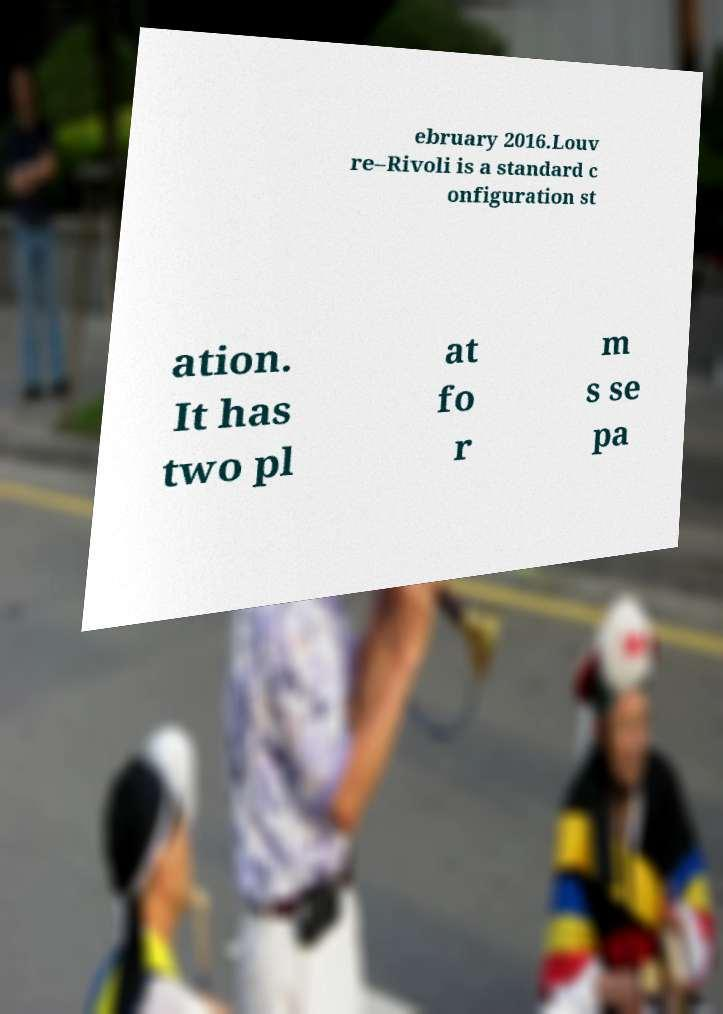Could you assist in decoding the text presented in this image and type it out clearly? ebruary 2016.Louv re–Rivoli is a standard c onfiguration st ation. It has two pl at fo r m s se pa 